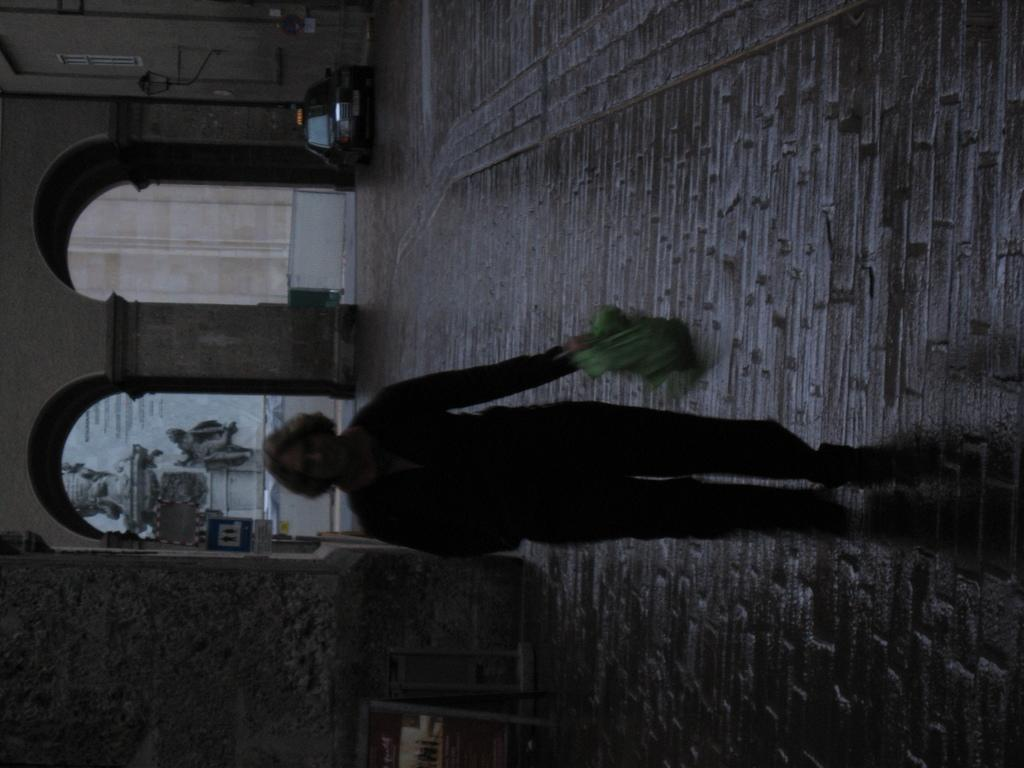What is the person in the image doing? There is a person walking on the road in the image. What type of structure can be seen in the image? There is a building in the image. What architectural feature is present in the image? There are arches in the image. What else can be seen on the road in the image? There are vehicles in the image. What type of paper is the person holding in the image? There is no paper visible in the image; the person is walking on the road. What is the purpose of the arches in the image? The purpose of the arches cannot be determined from the image alone, as it only shows their presence and not their function. 